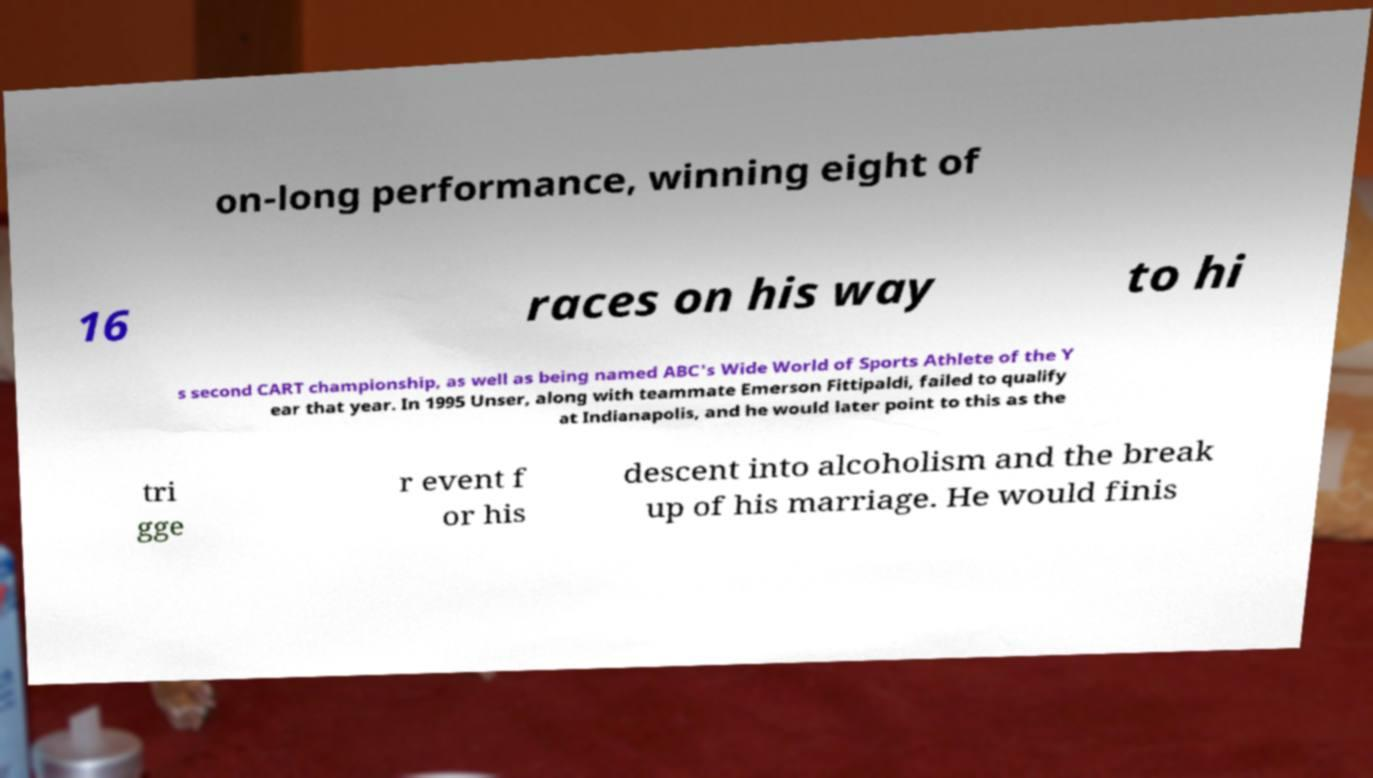For documentation purposes, I need the text within this image transcribed. Could you provide that? on-long performance, winning eight of 16 races on his way to hi s second CART championship, as well as being named ABC's Wide World of Sports Athlete of the Y ear that year. In 1995 Unser, along with teammate Emerson Fittipaldi, failed to qualify at Indianapolis, and he would later point to this as the tri gge r event f or his descent into alcoholism and the break up of his marriage. He would finis 